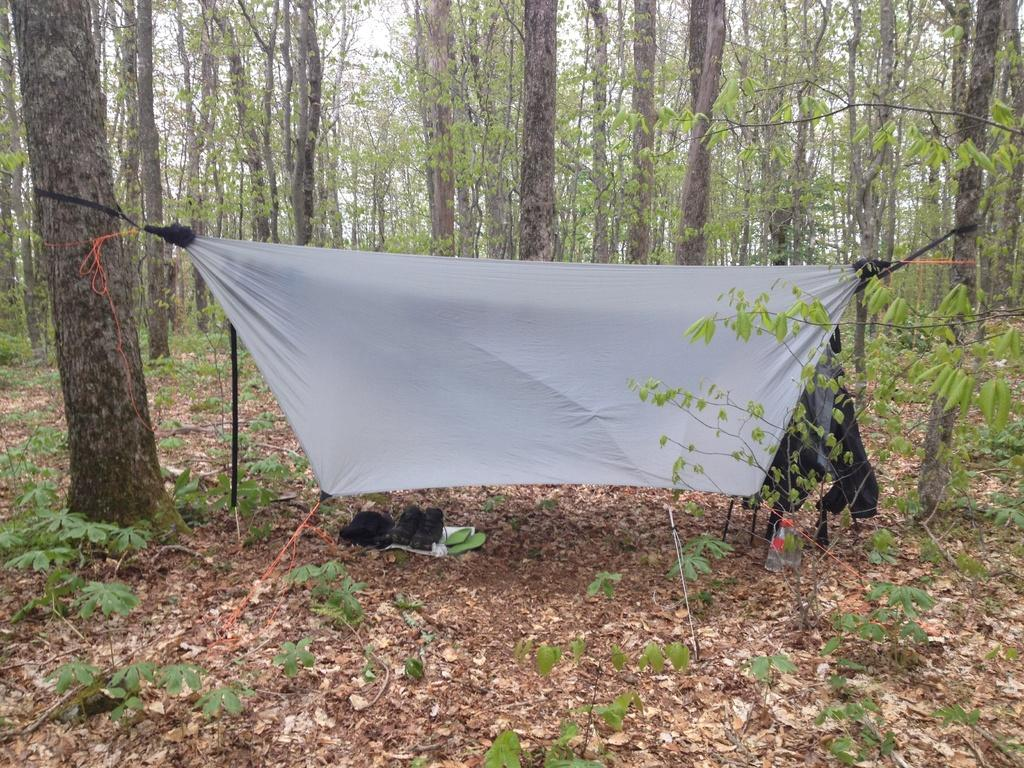What color is the cloth that is visible in the image? The cloth in the image is white. What type of footwear can be seen in the image? There are black shoes in the image. What object is present in the image that might contain a liquid? There is a bottle in the image. What other items in the image share the same color as the shoes? There are black color things in the image. What can be seen in the background of the image? There are trees in the background of the image. Where is the drain located in the image? There is no drain present in the image. What type of bed can be seen in the image? There is no bed present in the image. 